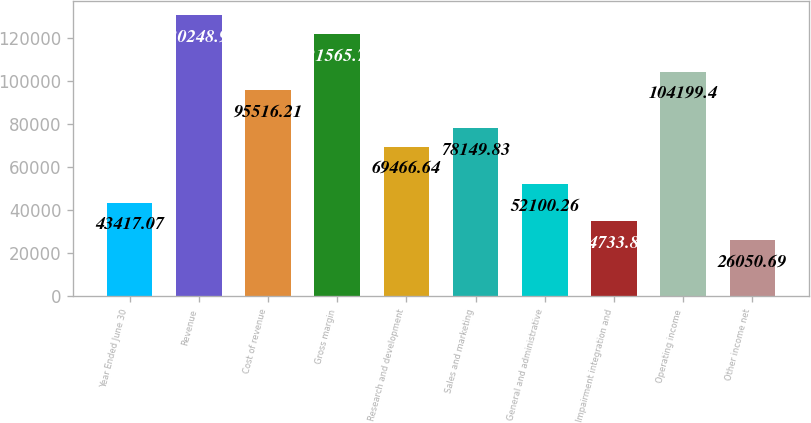Convert chart. <chart><loc_0><loc_0><loc_500><loc_500><bar_chart><fcel>Year Ended June 30<fcel>Revenue<fcel>Cost of revenue<fcel>Gross margin<fcel>Research and development<fcel>Sales and marketing<fcel>General and administrative<fcel>Impairment integration and<fcel>Operating income<fcel>Other income net<nl><fcel>43417.1<fcel>130249<fcel>95516.2<fcel>121566<fcel>69466.6<fcel>78149.8<fcel>52100.3<fcel>34733.9<fcel>104199<fcel>26050.7<nl></chart> 